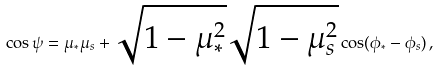Convert formula to latex. <formula><loc_0><loc_0><loc_500><loc_500>\cos \psi = \mu _ { * } \mu _ { s } + \sqrt { 1 - \mu _ { * } ^ { 2 } } \sqrt { 1 - \mu _ { s } ^ { 2 } } \cos ( \phi _ { * } - \phi _ { s } ) \, ,</formula> 